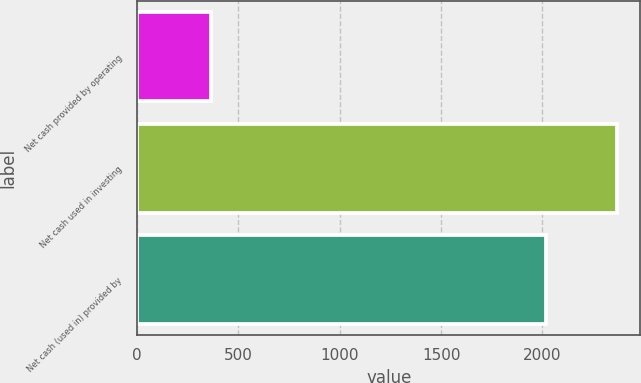<chart> <loc_0><loc_0><loc_500><loc_500><bar_chart><fcel>Net cash provided by operating<fcel>Net cash used in investing<fcel>Net cash (used in) provided by<nl><fcel>363.1<fcel>2365.7<fcel>2016.4<nl></chart> 